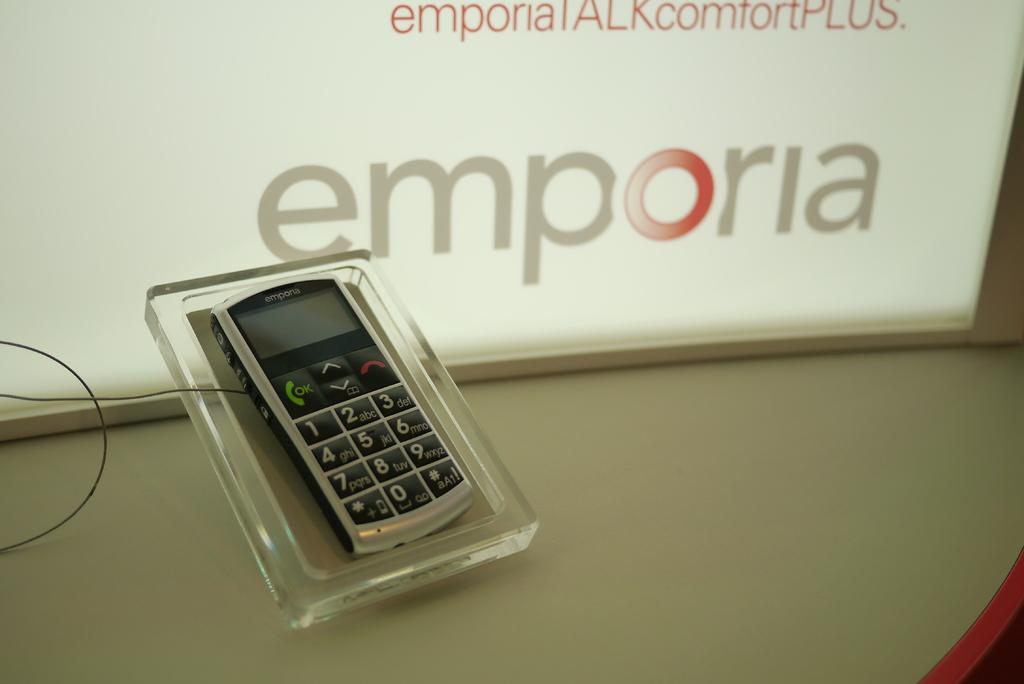<image>
Relay a brief, clear account of the picture shown. The mobile phone on display is an emporia phone. 